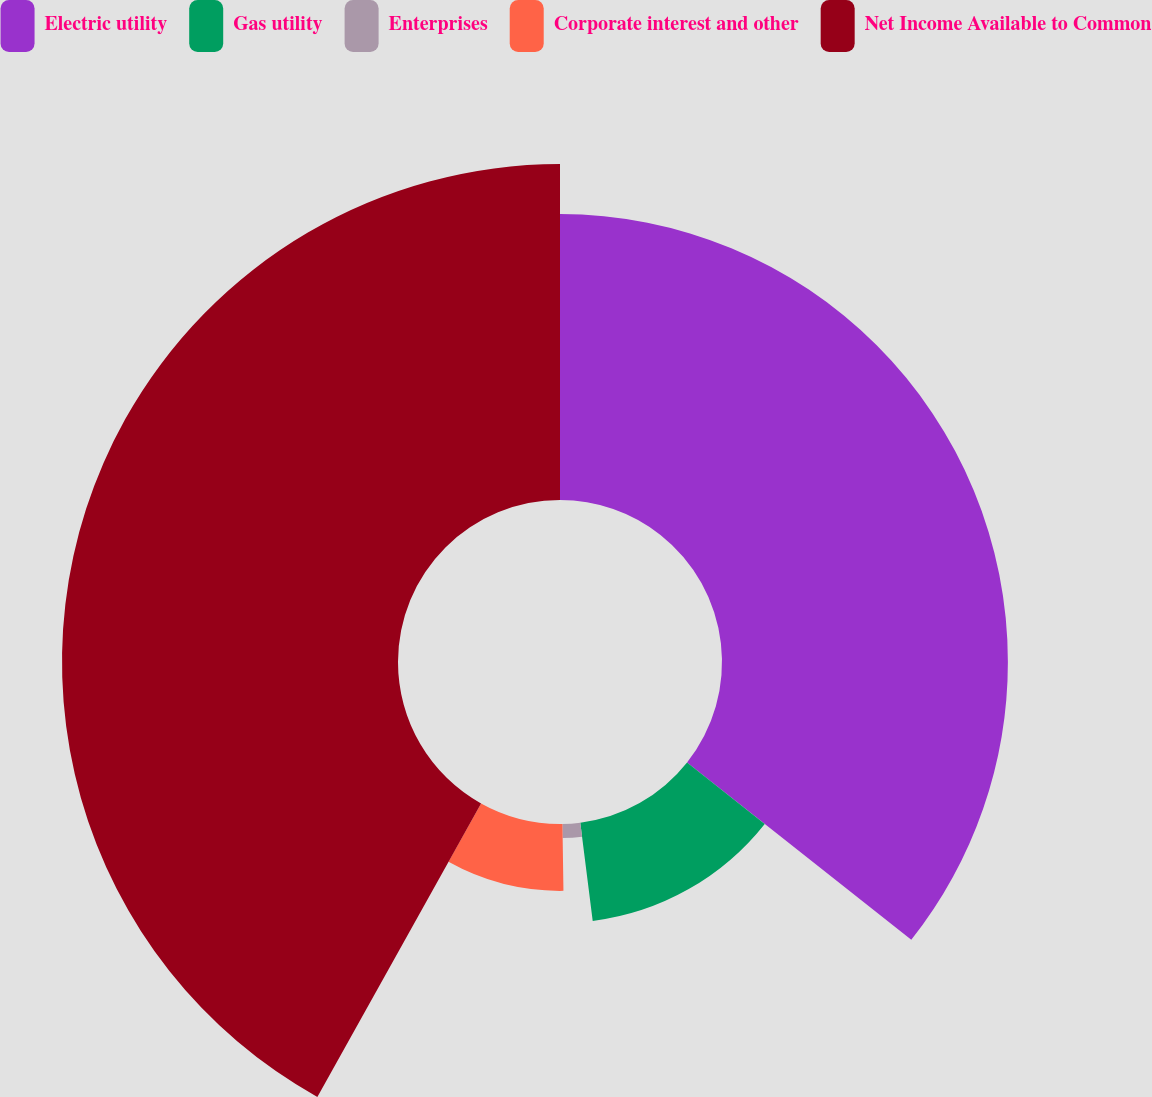<chart> <loc_0><loc_0><loc_500><loc_500><pie_chart><fcel>Electric utility<fcel>Gas utility<fcel>Enterprises<fcel>Corporate interest and other<fcel>Net Income Available to Common<nl><fcel>35.65%<fcel>12.35%<fcel>1.76%<fcel>8.34%<fcel>41.9%<nl></chart> 